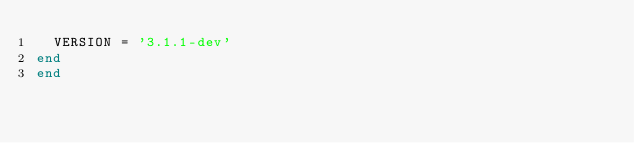<code> <loc_0><loc_0><loc_500><loc_500><_Ruby_>  VERSION = '3.1.1-dev'
end
end
</code> 